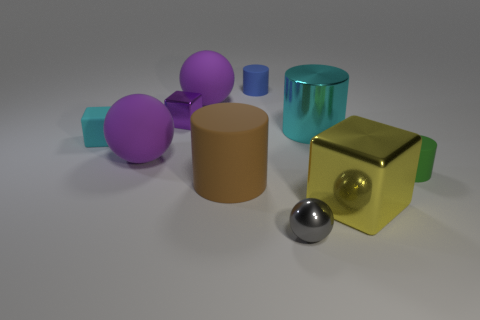Subtract all cyan blocks. Subtract all red cylinders. How many blocks are left? 2 Subtract all cubes. How many objects are left? 7 Add 7 purple balls. How many purple balls exist? 9 Subtract 0 green blocks. How many objects are left? 10 Subtract all large yellow blocks. Subtract all brown cylinders. How many objects are left? 8 Add 2 purple balls. How many purple balls are left? 4 